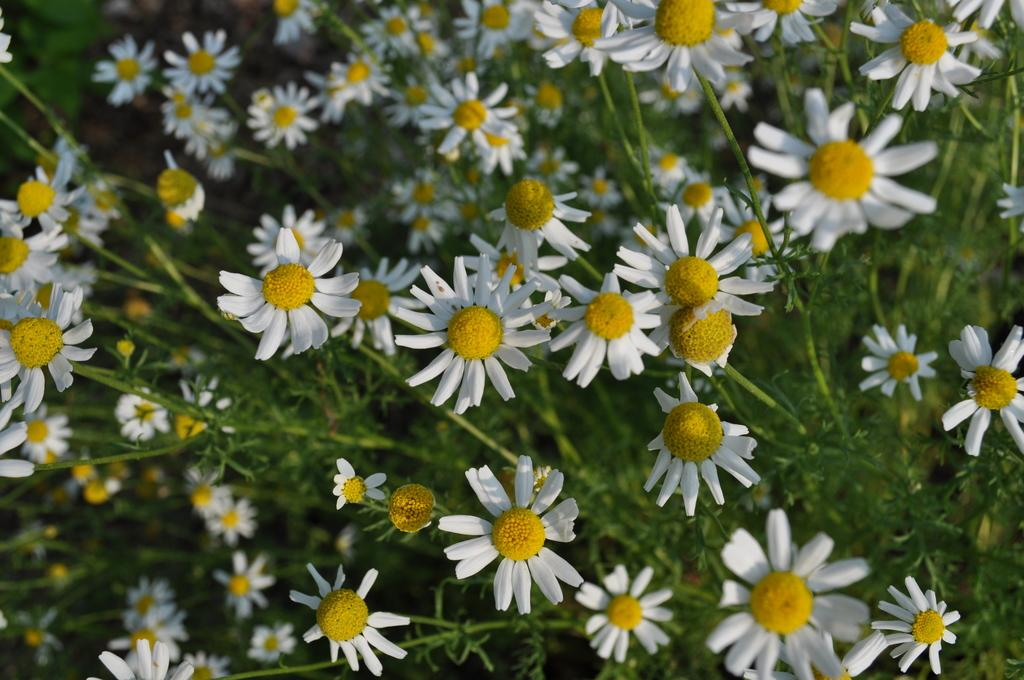What is the main subject of the image? There is a group of flowers in the image. What else can be seen in the image besides the flowers? There are plants in the background of the image. How would you describe the appearance of the background? The background appears blurry. What grade does the volleyball team receive for their performance in the image? There is no volleyball team or performance present in the image; it features a group of flowers and plants in the background. 